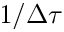<formula> <loc_0><loc_0><loc_500><loc_500>1 / \Delta \tau</formula> 